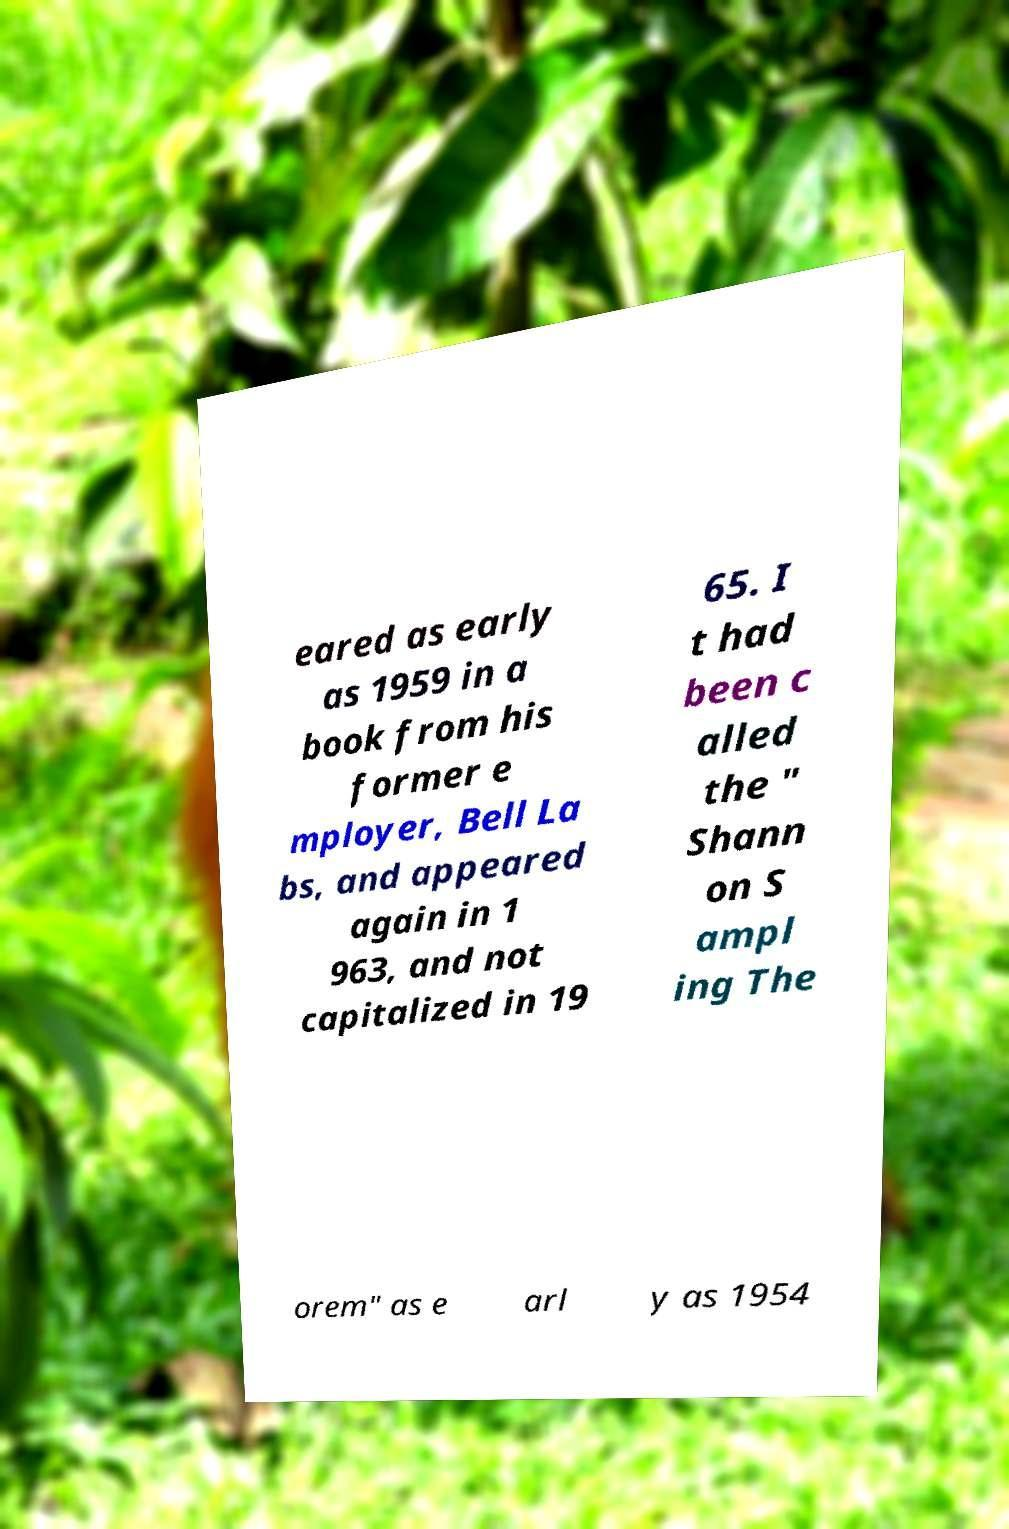Can you read and provide the text displayed in the image?This photo seems to have some interesting text. Can you extract and type it out for me? eared as early as 1959 in a book from his former e mployer, Bell La bs, and appeared again in 1 963, and not capitalized in 19 65. I t had been c alled the " Shann on S ampl ing The orem" as e arl y as 1954 